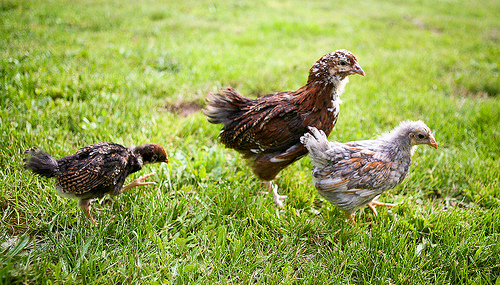<image>
Is the hen to the left of the hen? Yes. From this viewpoint, the hen is positioned to the left side relative to the hen. 